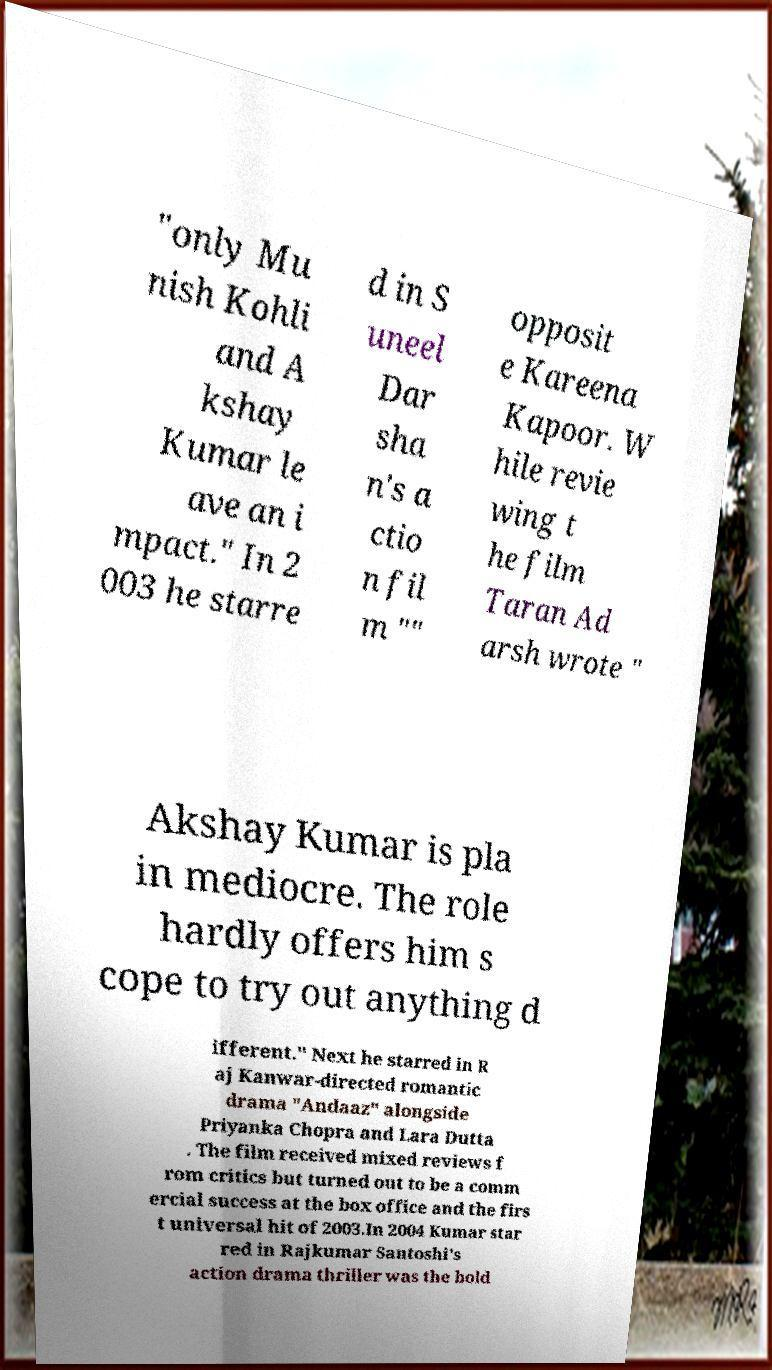What messages or text are displayed in this image? I need them in a readable, typed format. "only Mu nish Kohli and A kshay Kumar le ave an i mpact." In 2 003 he starre d in S uneel Dar sha n's a ctio n fil m "" opposit e Kareena Kapoor. W hile revie wing t he film Taran Ad arsh wrote " Akshay Kumar is pla in mediocre. The role hardly offers him s cope to try out anything d ifferent." Next he starred in R aj Kanwar-directed romantic drama "Andaaz" alongside Priyanka Chopra and Lara Dutta . The film received mixed reviews f rom critics but turned out to be a comm ercial success at the box office and the firs t universal hit of 2003.In 2004 Kumar star red in Rajkumar Santoshi's action drama thriller was the bold 